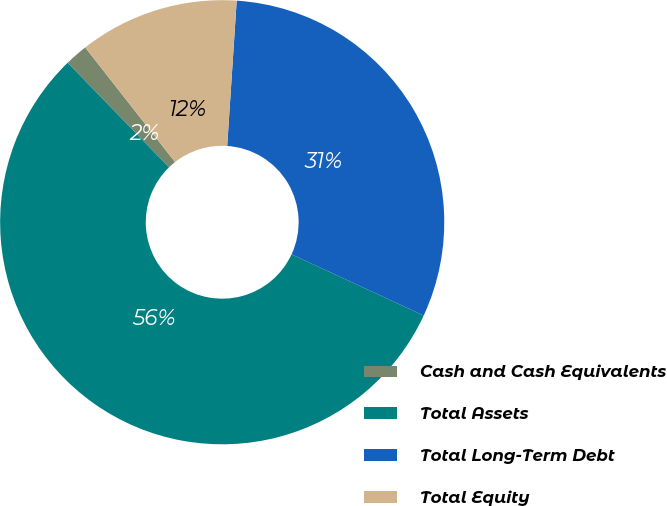<chart> <loc_0><loc_0><loc_500><loc_500><pie_chart><fcel>Cash and Cash Equivalents<fcel>Total Assets<fcel>Total Long-Term Debt<fcel>Total Equity<nl><fcel>1.67%<fcel>55.85%<fcel>30.86%<fcel>11.62%<nl></chart> 